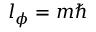Convert formula to latex. <formula><loc_0><loc_0><loc_500><loc_500>l _ { \phi } = m \hbar</formula> 